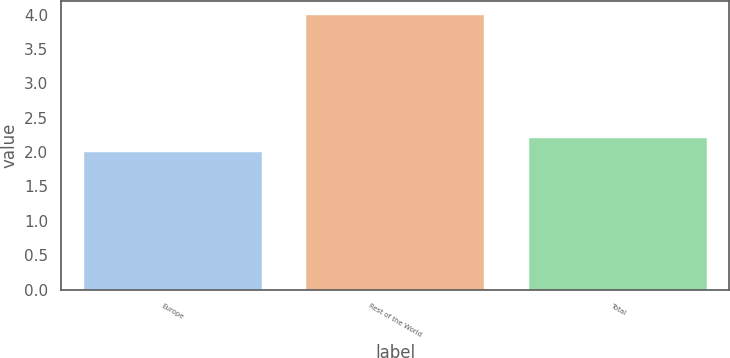Convert chart. <chart><loc_0><loc_0><loc_500><loc_500><bar_chart><fcel>Europe<fcel>Rest of the World<fcel>Total<nl><fcel>2<fcel>4<fcel>2.2<nl></chart> 